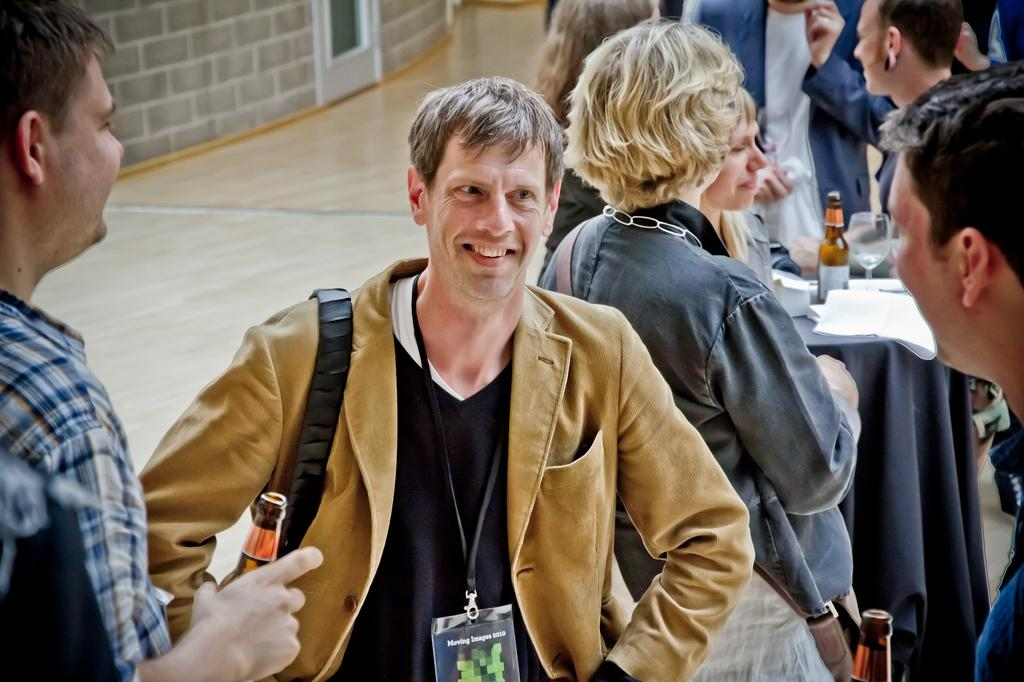What can be seen in the image? There are people standing in the image, along with a table, a bottle, a glass, and papers on the table. What is the location of the table in the image? The table is in the image. What is on the table? There is a bottle, a glass, and papers on the table. What is visible in the background of the image? There is a wall in the background of the image. What is the surface on which the table and people are standing? There is a floor in the image. How many jars of jelly can be seen on the table in the image? There are no jars of jelly present in the image. Can you describe the running shoes worn by the people in the image? There is no mention of running shoes or any shoes worn by the people in the image. 